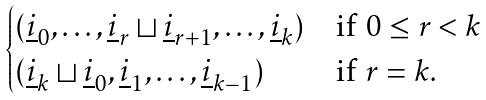<formula> <loc_0><loc_0><loc_500><loc_500>\begin{cases} ( { \underline { i } _ { 0 } } , \dots , { \underline { i } _ { r } } \sqcup { \underline { i } _ { r + 1 } } , \dots , { \underline { i } _ { k } } ) & \text {if $0\leq r < k$} \\ ( { \underline { i } _ { k } } \sqcup { \underline { i } _ { 0 } } , { \underline { i } _ { 1 } } , \dots , { \underline { i } _ { k - 1 } } ) & \text {if $r=k.$} \end{cases}</formula> 